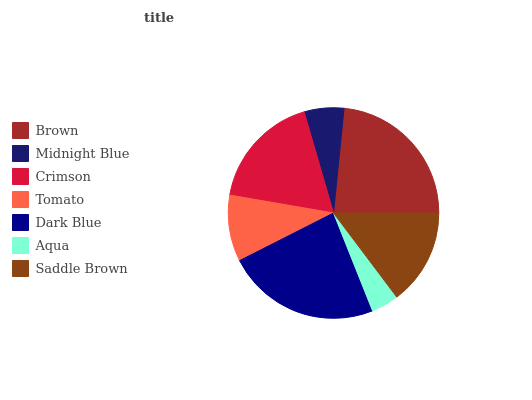Is Aqua the minimum?
Answer yes or no. Yes. Is Dark Blue the maximum?
Answer yes or no. Yes. Is Midnight Blue the minimum?
Answer yes or no. No. Is Midnight Blue the maximum?
Answer yes or no. No. Is Brown greater than Midnight Blue?
Answer yes or no. Yes. Is Midnight Blue less than Brown?
Answer yes or no. Yes. Is Midnight Blue greater than Brown?
Answer yes or no. No. Is Brown less than Midnight Blue?
Answer yes or no. No. Is Saddle Brown the high median?
Answer yes or no. Yes. Is Saddle Brown the low median?
Answer yes or no. Yes. Is Dark Blue the high median?
Answer yes or no. No. Is Tomato the low median?
Answer yes or no. No. 